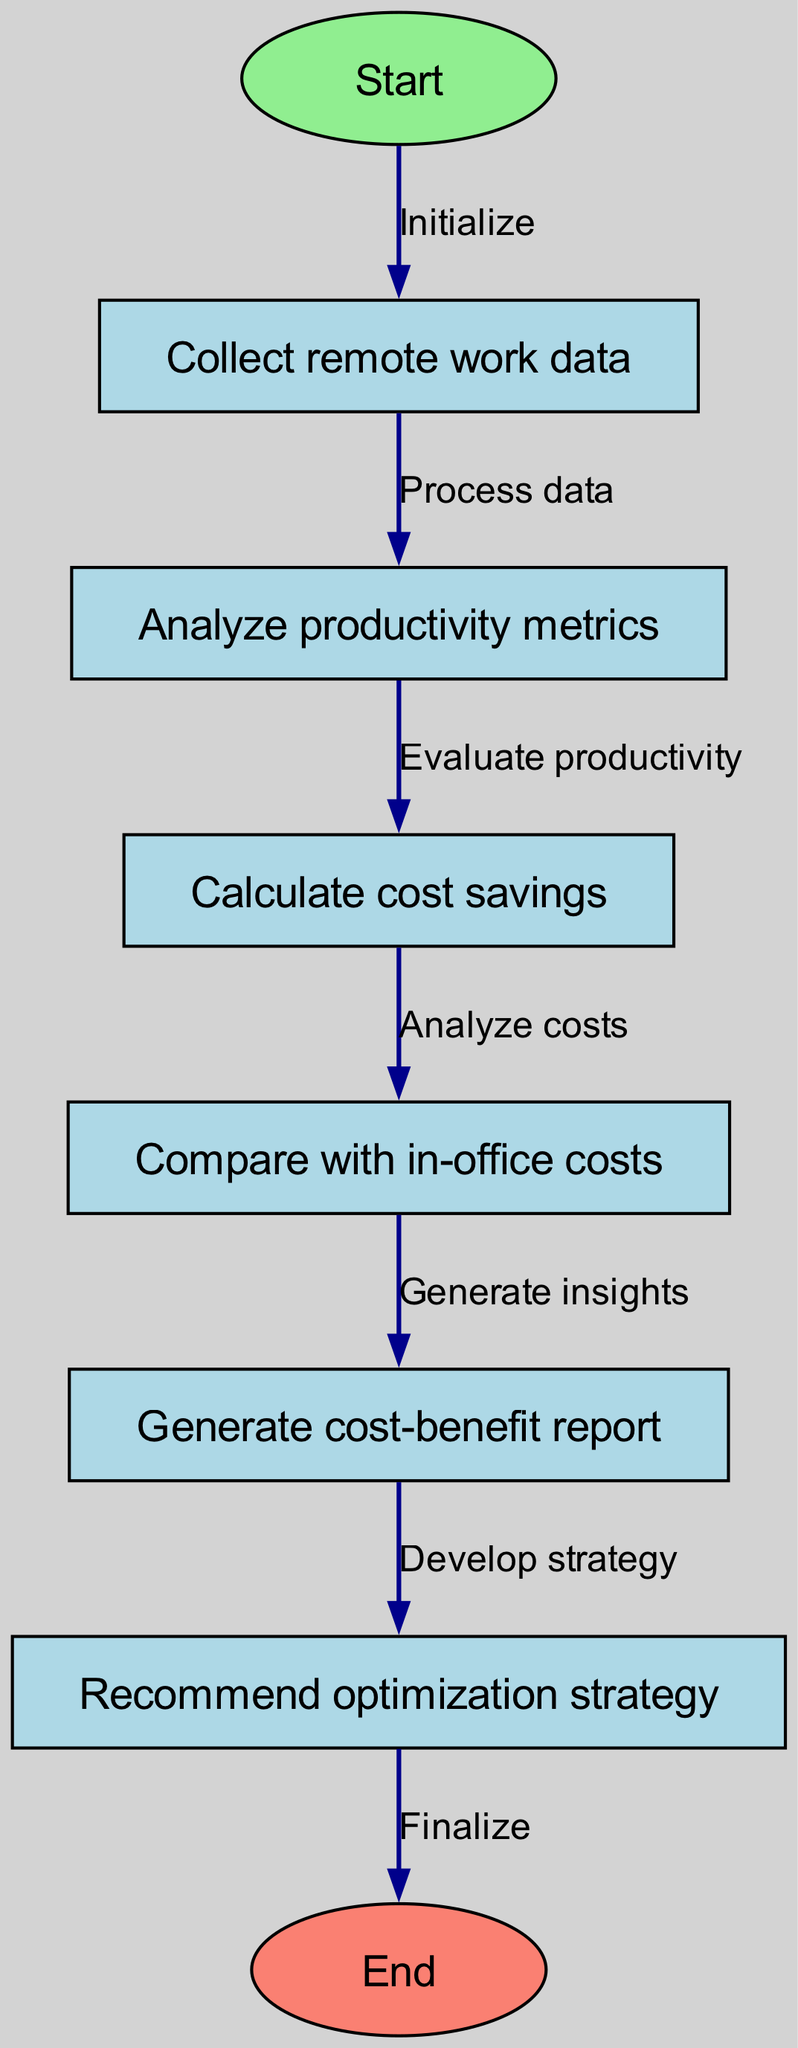What is the first step in the flowchart? The first node in the flowchart is "Start", indicated by node ID 1, which is where the process begins.
Answer: Start How many nodes are there in total? By counting the nodes listed in the data, there are eight nodes present in the diagram.
Answer: Eight What does the edge from node 4 to node 5 signify? The edge from node 4 ("Calculate cost savings") to node 5 ("Compare with in-office costs") signifies a transition where cost savings are analyzed for comparison with in-office costs.
Answer: Analyze costs What is the last action performed in the flowchart? The last node before reaching the "End" node is "Recommend optimization strategy", which is represented as node ID 7, indicating the final step in the process.
Answer: Recommend optimization strategy Which node is directly connected to the "Generate cost-benefit report"? The "Generate cost-benefit report" node, represented as node ID 6, is directly connected to "Compare with in-office costs" (node ID 5).
Answer: Compare with in-office costs What is the function of the node with ID 3? Node ID 3 is labeled "Analyze productivity metrics", and its function is to analyze the productivity data collected in the previous step before calculating any cost savings.
Answer: Analyze productivity metrics How does the flow from node 2 to node 3 work? The flow from node 2 ("Collect remote work data") to node 3 ("Analyze productivity metrics") occurs after processing the collected data, meaning the analysis of productivity metrics takes place after data collection.
Answer: Process data What is the relationship between node 6 and node 7? The edge connecting node 6 ("Generate cost-benefit report") to node 7 ("Recommend optimization strategy") indicates that developing an optimization strategy is based on the insights gained from the cost-benefit report generated prior.
Answer: Develop strategy 